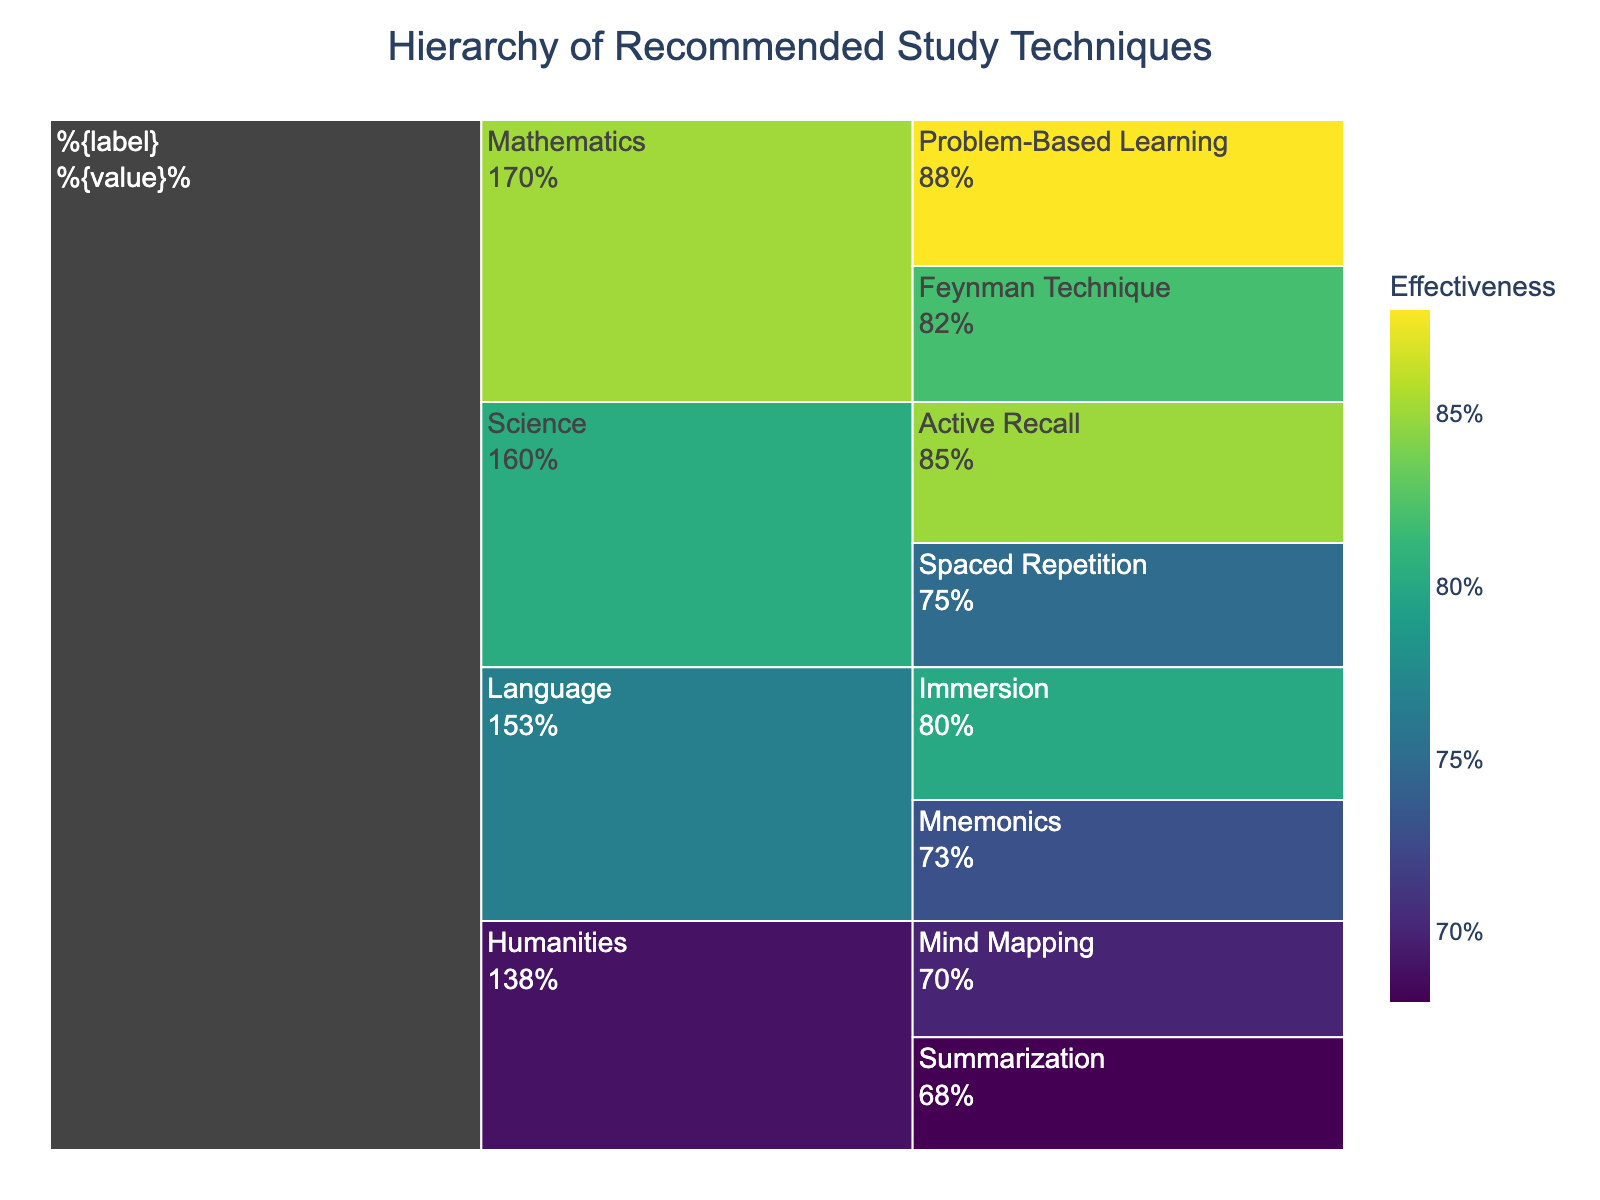What is the title of the chart? The title of the chart is placed at the top and generally summarizes the main idea of the visualization. Here, it's "Hierarchy of Recommended Study Techniques".
Answer: Hierarchy of Recommended Study Techniques Which subject has the highest effectiveness for a technique, and what is that technique? To find the subject with the highest effectiveness, look for the highest value in the chart. Problem-Based Learning under Mathematics has the highest effectiveness at 88%.
Answer: Mathematics, Problem-Based Learning What is the least effective technique for Humanities, and what is its effectiveness? By looking at the branches under Humanities, identify the technique with the lowest effectiveness number. It is Summarization with an effectiveness of 68%.
Answer: Summarization, 68% Compare the effectiveness of the Feynman Technique and Active Recall. Which is more effective and by how much? Locate both techniques and compare their effectiveness values. Feynman Technique has an effectiveness of 82%, and Active Recall has an effectiveness of 85%. The difference is 85% - 82% = 3%.
Answer: Active Recall, 3% What is the combined effectiveness of all techniques under the subject Language? Sum the effectiveness values for all techniques under Language. Immersion (80%) + Mnemonics (73%) = 153%.
Answer: 153% Is Spaced Repetition more effective than Mind Mapping? Compare the effectiveness values of both techniques. Spaced Repetition is 75% effective, and Mind Mapping is 70% effective, so Spaced Repetition is more effective.
Answer: Yes What’s the average effectiveness of the techniques under Science? To find the average, add the effectiveness values of all techniques under Science and divide by the number of techniques. (85% + 75%) / 2 = 80%.
Answer: 80% Which color is associated with the highest effectiveness value, and what is this value? The color gradient indicates effectiveness. The highest value (88%) is associated with the darkest shade in the Viridis color scale.
Answer: Darkest shade, 88% What percentage of effectiveness do all techniques in Humanities contribute to, relative to the overall highest effectiveness in the chart? The highest effectiveness is 88%. Sum the effectiveness for Humanities (70% Mind Mapping + 68% Summarization = 138%). Calculate 138% / 88% ≈ 1.57 = 157%.
Answer: 157% What are the label and value displayed inside the smallest segment in the chart? Identify the segment with the smallest area. The smallest segment is Summarization under Humanities with 68%.
Answer: Summarization, 68% 